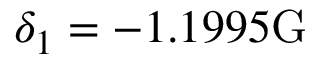Convert formula to latex. <formula><loc_0><loc_0><loc_500><loc_500>\delta _ { 1 } = - 1 . 1 9 9 5 G</formula> 